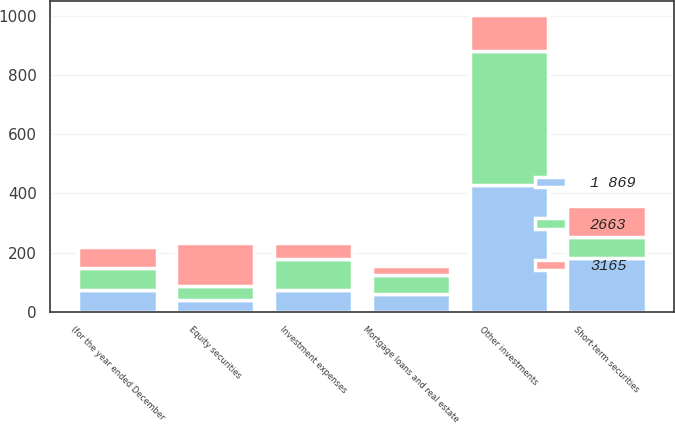Convert chart. <chart><loc_0><loc_0><loc_500><loc_500><stacked_bar_chart><ecel><fcel>(for the year ended December<fcel>Equity securities<fcel>Short-term securities<fcel>Mortgage loans and real estate<fcel>Other investments<fcel>Investment expenses<nl><fcel>1 869<fcel>73<fcel>41<fcel>182<fcel>58<fcel>427<fcel>73<nl><fcel>2663<fcel>73<fcel>47<fcel>70<fcel>67<fcel>456<fcel>105<nl><fcel>3165<fcel>73<fcel>143<fcel>107<fcel>28<fcel>119<fcel>55<nl></chart> 